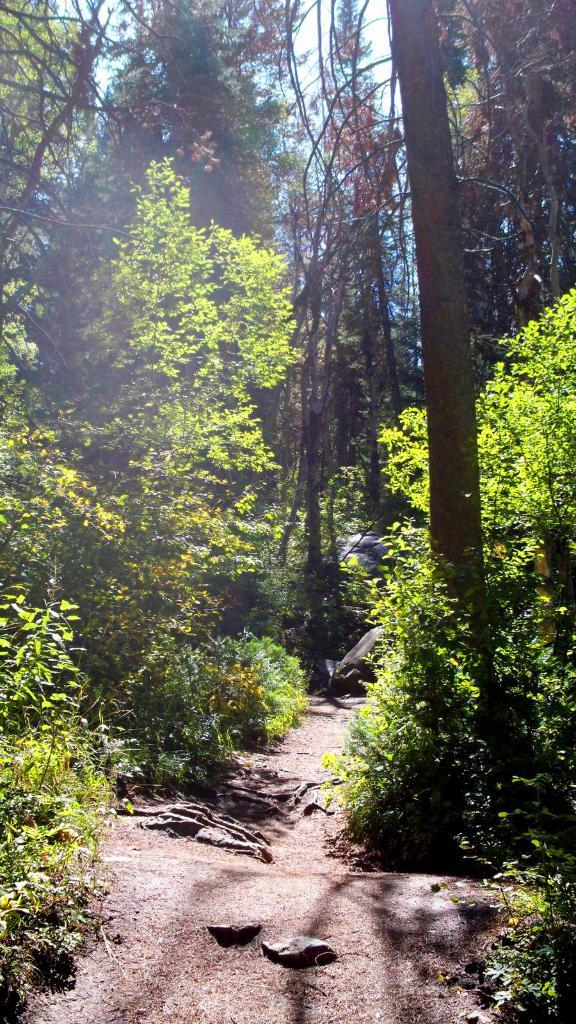What type of natural environment is depicted in the image? There is a forest in the image. What are the main features of the forest? Trees are present in the forest. What can be seen in the sky in the image? The sky is visible in the image. Is there any man-made structure visible in the image? Yes, there is a road visible in the image. How many bridges can be seen crossing the river in the image? There is no river or bridge present in the image; it features a forest with trees and a visible sky. What type of government policy is being discussed in the image? There is no discussion or reference to any government policy in the image; it simply depicts a forest with trees and a visible sky. 